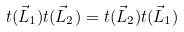Convert formula to latex. <formula><loc_0><loc_0><loc_500><loc_500>t ( \vec { L } _ { 1 } ) t ( \vec { L } _ { 2 } ) = t ( \vec { L } _ { 2 } ) t ( \vec { L } _ { 1 } )</formula> 